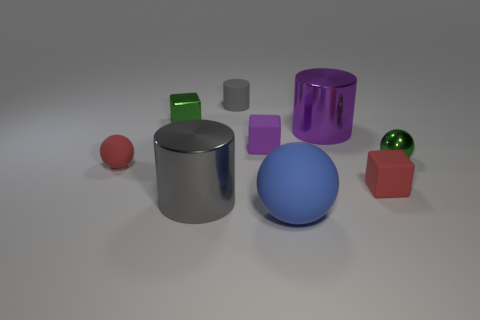Is there a tiny yellow object?
Offer a terse response. No. What is the shape of the tiny green object that is behind the thing that is right of the red matte block?
Ensure brevity in your answer.  Cube. What number of things are big metallic cylinders that are on the right side of the tiny matte cylinder or tiny objects right of the big blue matte thing?
Make the answer very short. 3. What material is the blue thing that is the same size as the purple cylinder?
Keep it short and to the point. Rubber. The matte cylinder has what color?
Give a very brief answer. Gray. What is the material of the ball that is both behind the large matte ball and right of the small gray matte thing?
Provide a succinct answer. Metal. There is a big metallic cylinder that is to the left of the big thing that is behind the big gray object; are there any tiny red blocks in front of it?
Your answer should be compact. No. There is a metallic cylinder that is the same color as the matte cylinder; what size is it?
Your response must be concise. Large. Are there any tiny green metallic objects left of the gray rubber cylinder?
Provide a succinct answer. Yes. How many other objects are the same shape as the large purple shiny object?
Keep it short and to the point. 2. 